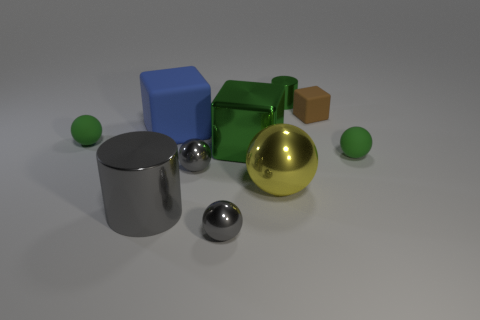There is a thing that is in front of the small cylinder and behind the blue cube; what is its shape?
Your answer should be compact. Cube. There is another rubber thing that is the same shape as the big blue object; what size is it?
Provide a succinct answer. Small. There is a tiny matte thing that is the same shape as the big green metallic object; what color is it?
Keep it short and to the point. Brown. Are there any big blue blocks that are to the right of the tiny metallic thing that is behind the rubber ball that is on the left side of the big green metal cube?
Your answer should be compact. No. What number of small brown objects have the same material as the large blue object?
Give a very brief answer. 1. There is a cylinder that is left of the tiny green metallic cylinder; is it the same size as the green matte sphere that is to the right of the blue cube?
Your answer should be compact. No. What color is the metallic thing that is behind the small green sphere left of the small rubber thing behind the large blue matte block?
Your answer should be very brief. Green. Are there any yellow objects of the same shape as the brown rubber object?
Your answer should be very brief. No. Is the number of balls that are behind the big blue block the same as the number of small green objects to the left of the large ball?
Your response must be concise. No. Does the green object that is in front of the big green object have the same shape as the big blue object?
Give a very brief answer. No. 